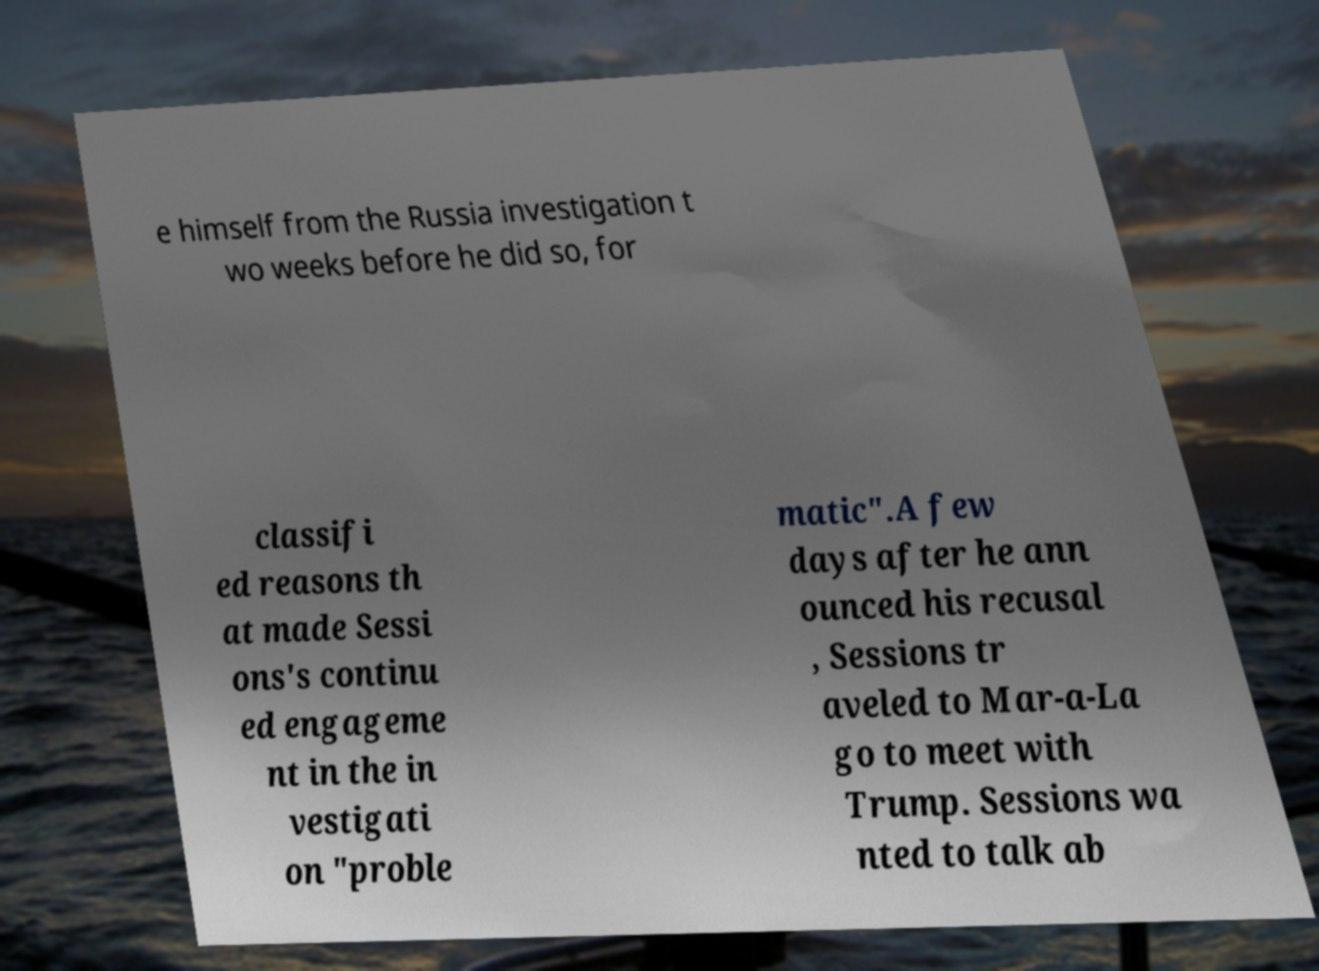For documentation purposes, I need the text within this image transcribed. Could you provide that? e himself from the Russia investigation t wo weeks before he did so, for classifi ed reasons th at made Sessi ons's continu ed engageme nt in the in vestigati on "proble matic".A few days after he ann ounced his recusal , Sessions tr aveled to Mar-a-La go to meet with Trump. Sessions wa nted to talk ab 